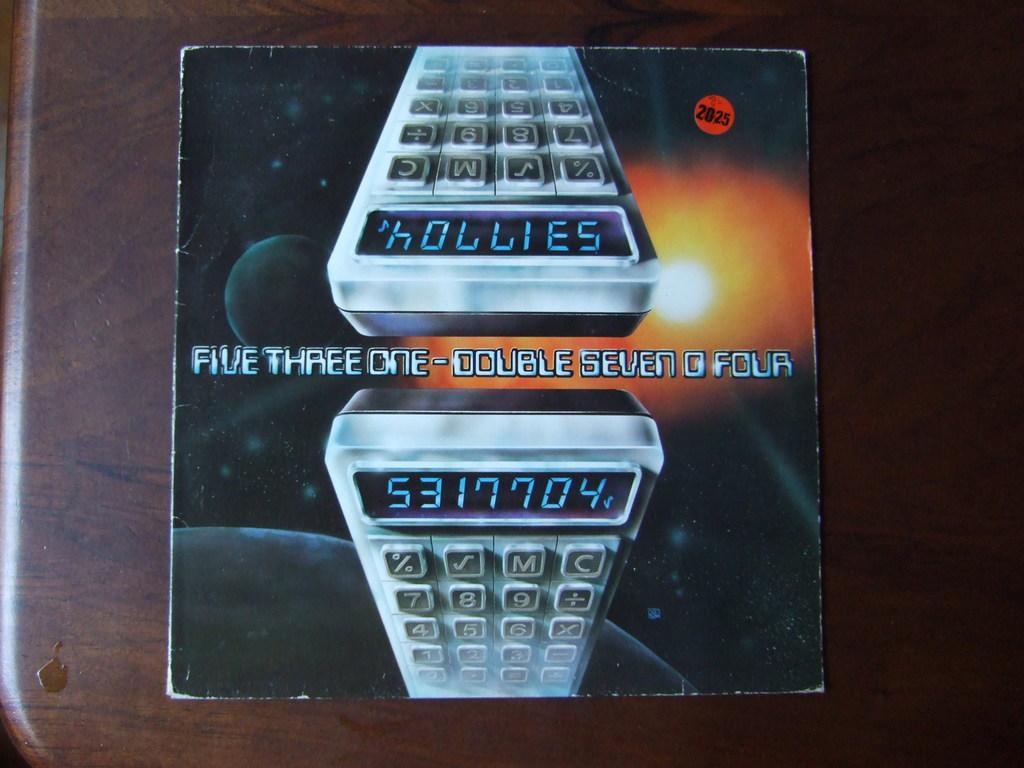Is the number on the calculator also a name if inverted and mirrored?
Keep it short and to the point. Yes. What numbers are being spelled out in the center of the image?
Keep it short and to the point. 5317704. 